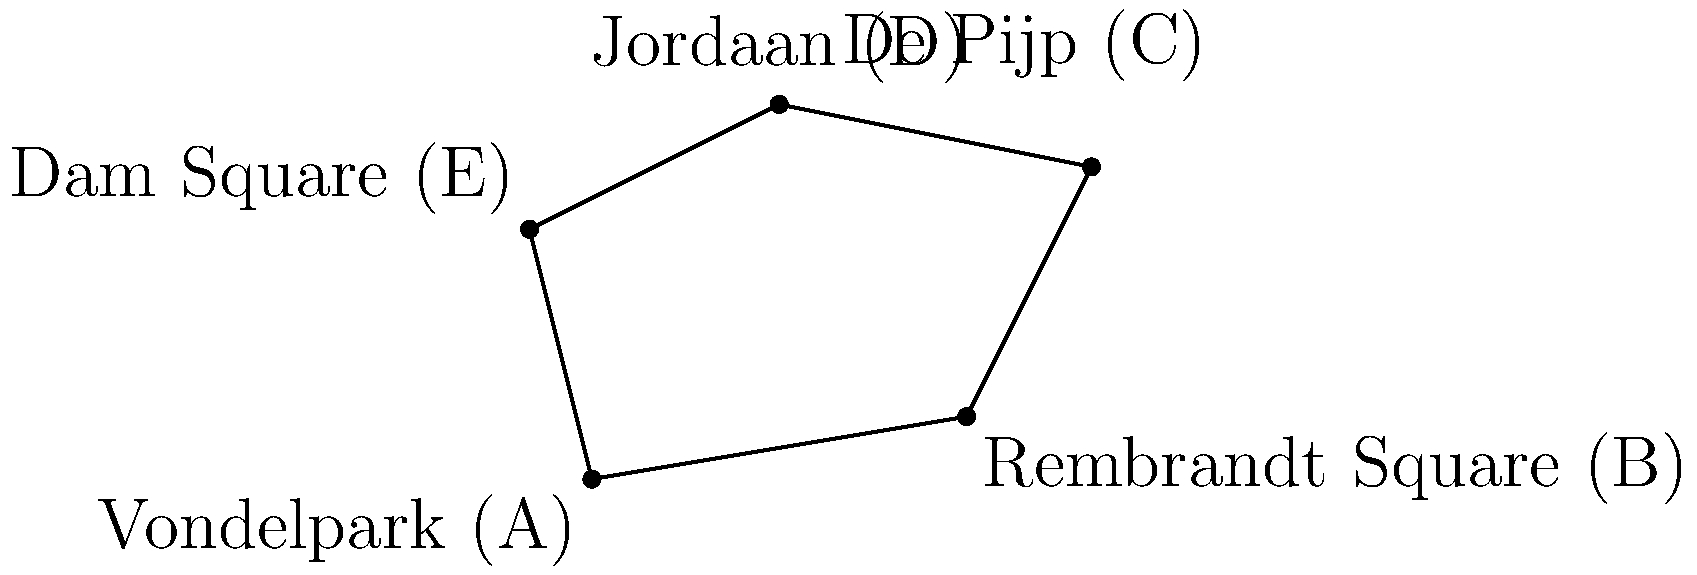On a map of Amsterdam, five popular expat hangout spots are marked: Vondelpark (A), Rembrandt Square (B), De Pijp (C), Jordaan (D), and Dam Square (E). The coordinates of these points in kilometers from the city center are A(0,0), B(6,1), C(8,5), D(3,6), and E(-1,4). Calculate the area of the polygon formed by connecting these points in square kilometers. To calculate the area of the polygon, we can use the Shoelace formula (also known as the surveyor's formula). The formula for a polygon with n vertices $(x_1, y_1), (x_2, y_2), ..., (x_n, y_n)$ is:

$$Area = \frac{1}{2}|(x_1y_2 + x_2y_3 + ... + x_ny_1) - (y_1x_2 + y_2x_3 + ... + y_nx_1)|$$

Let's apply this formula to our polygon:

1) First, let's list our points in order:
   A(0,0), B(6,1), C(8,5), D(3,6), E(-1,4)

2) Now, let's calculate the first part of the formula:
   $(0 \cdot 1 + 6 \cdot 5 + 8 \cdot 6 + 3 \cdot 4 + (-1) \cdot 0) = 0 + 30 + 48 + 12 + 0 = 90$

3) Next, let's calculate the second part of the formula:
   $(0 \cdot 6 + 1 \cdot 8 + 5 \cdot 3 + 6 \cdot (-1) + 4 \cdot 0) = 0 + 8 + 15 - 6 + 0 = 17$

4) Now, we subtract these values and take the absolute value:
   $|90 - 17| = |73| = 73$

5) Finally, we divide by 2:
   $\frac{73}{2} = 36.5$

Therefore, the area of the polygon is 36.5 square kilometers.
Answer: 36.5 sq km 